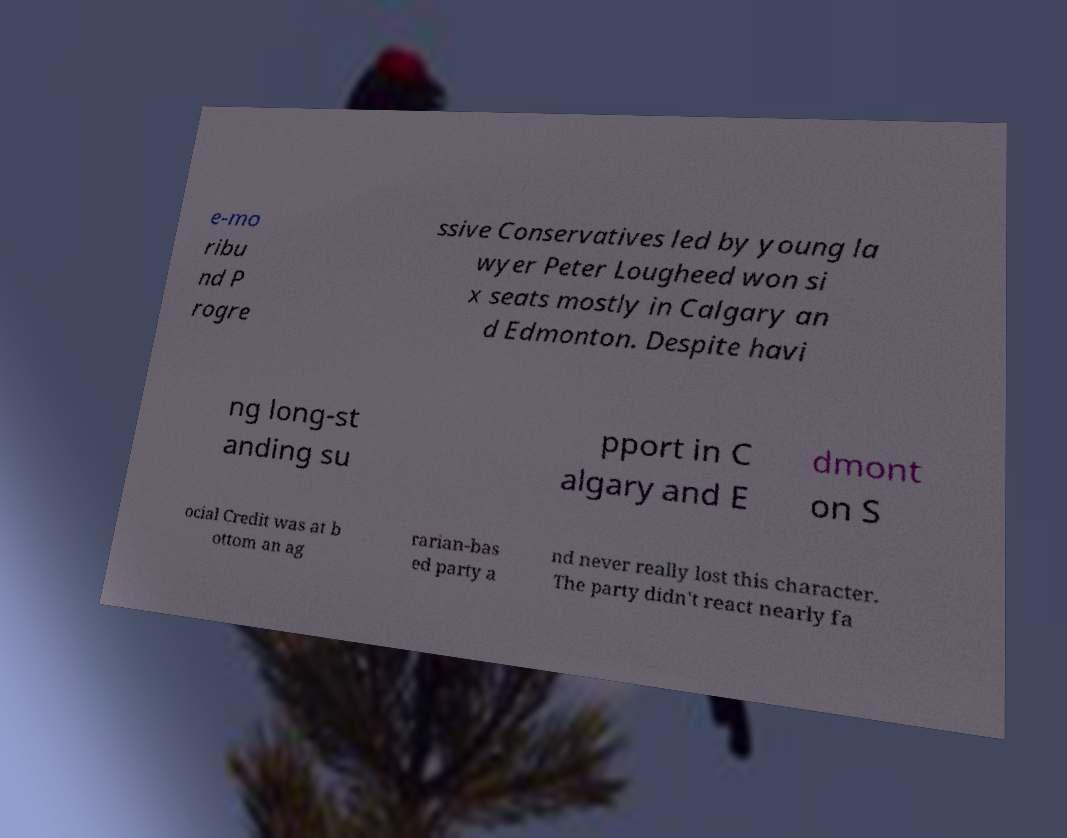I need the written content from this picture converted into text. Can you do that? e-mo ribu nd P rogre ssive Conservatives led by young la wyer Peter Lougheed won si x seats mostly in Calgary an d Edmonton. Despite havi ng long-st anding su pport in C algary and E dmont on S ocial Credit was at b ottom an ag rarian-bas ed party a nd never really lost this character. The party didn't react nearly fa 